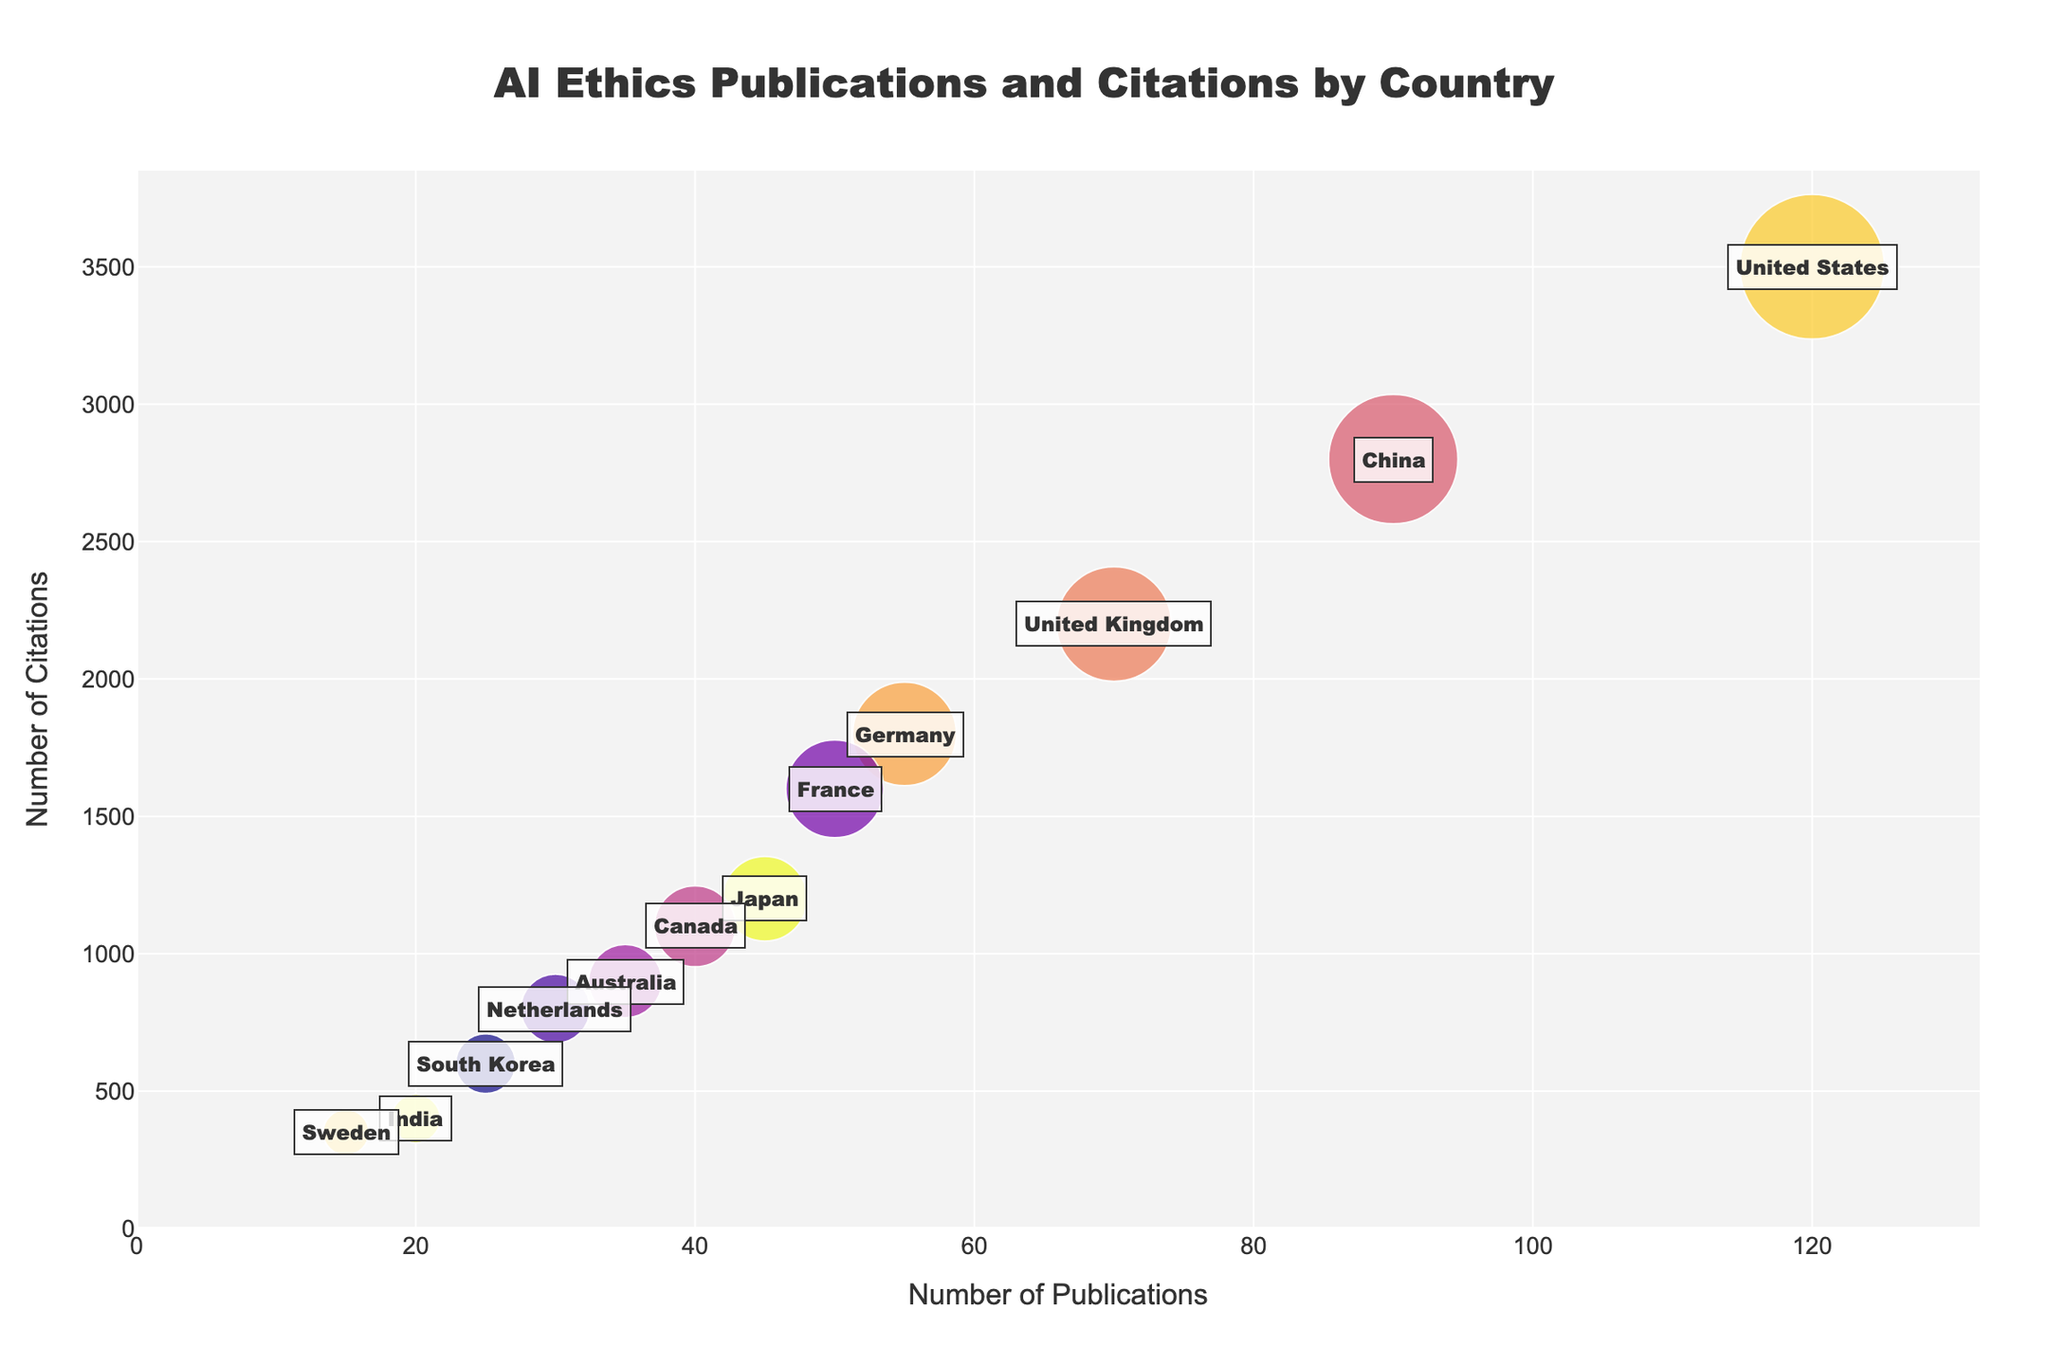What is the title of the plot? By looking at the top section of the plot, you can see the text that describes the subject of the plot.
Answer: AI Ethics Publications and Citations by Country Which country has the highest number of publications? Identify the country with the bubble located farthest to the right on the x-axis.
Answer: United States What is the number of citations for France? Locate France on the plot and read the value on the y-axis where France's bubble is placed.
Answer: 1600 How many countries have more than 50 publications? Count the number of bubbles where the x-axis value exceeds 50.
Answer: 4 Which country has the largest bubble and what does it represent? Identify the country with the bubble with the largest size and refer to what the bubble size represents in the plot description.
Answer: United States, Citations Which country has fewer publications, India or Sweden? Compare the x-axis values for India and Sweden and determine which one is smaller.
Answer: Sweden Which country has a bubble close to Australia's but has more citations? Identify the bubble near Australia's position on the x-axis, then compare their y-axis values to see which one is higher.
Answer: France Which country has the lowest number of citations? Look for the bubble closest to the bottom of the y-axis and identify its label.
Answer: Sweden 